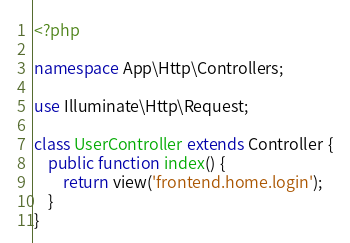<code> <loc_0><loc_0><loc_500><loc_500><_PHP_><?php

namespace App\Http\Controllers;

use Illuminate\Http\Request;

class UserController extends Controller {
    public function index() {
        return view('frontend.home.login');
    }
}
</code> 